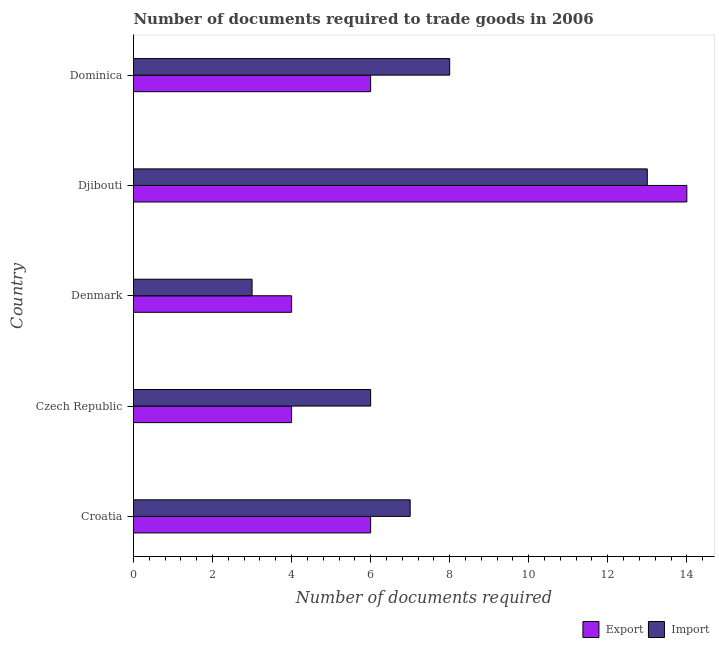How many different coloured bars are there?
Give a very brief answer. 2. How many bars are there on the 2nd tick from the top?
Offer a terse response. 2. What is the label of the 4th group of bars from the top?
Offer a terse response. Czech Republic. In how many cases, is the number of bars for a given country not equal to the number of legend labels?
Provide a succinct answer. 0. What is the number of documents required to import goods in Czech Republic?
Provide a succinct answer. 6. Across all countries, what is the maximum number of documents required to export goods?
Your response must be concise. 14. In which country was the number of documents required to import goods maximum?
Provide a succinct answer. Djibouti. In which country was the number of documents required to export goods minimum?
Provide a short and direct response. Czech Republic. What is the total number of documents required to import goods in the graph?
Your answer should be very brief. 37. What is the difference between the number of documents required to import goods in Denmark and the number of documents required to export goods in Dominica?
Your response must be concise. -3. What is the difference between the number of documents required to export goods and number of documents required to import goods in Croatia?
Offer a very short reply. -1. What is the ratio of the number of documents required to export goods in Croatia to that in Djibouti?
Provide a short and direct response. 0.43. Is the difference between the number of documents required to export goods in Czech Republic and Djibouti greater than the difference between the number of documents required to import goods in Czech Republic and Djibouti?
Offer a very short reply. No. Is the sum of the number of documents required to import goods in Denmark and Dominica greater than the maximum number of documents required to export goods across all countries?
Offer a terse response. No. What does the 2nd bar from the top in Croatia represents?
Your answer should be compact. Export. What does the 1st bar from the bottom in Croatia represents?
Make the answer very short. Export. How many bars are there?
Your response must be concise. 10. Are all the bars in the graph horizontal?
Give a very brief answer. Yes. Does the graph contain any zero values?
Offer a very short reply. No. Does the graph contain grids?
Make the answer very short. No. Where does the legend appear in the graph?
Ensure brevity in your answer.  Bottom right. What is the title of the graph?
Keep it short and to the point. Number of documents required to trade goods in 2006. Does "GDP" appear as one of the legend labels in the graph?
Give a very brief answer. No. What is the label or title of the X-axis?
Offer a terse response. Number of documents required. What is the Number of documents required in Import in Croatia?
Give a very brief answer. 7. What is the Number of documents required in Export in Czech Republic?
Your response must be concise. 4. What is the Number of documents required in Import in Czech Republic?
Your answer should be very brief. 6. What is the Number of documents required in Export in Denmark?
Ensure brevity in your answer.  4. What is the Number of documents required of Import in Denmark?
Your response must be concise. 3. What is the Number of documents required in Import in Djibouti?
Ensure brevity in your answer.  13. What is the Number of documents required in Export in Dominica?
Make the answer very short. 6. Across all countries, what is the minimum Number of documents required of Export?
Provide a short and direct response. 4. What is the total Number of documents required of Import in the graph?
Give a very brief answer. 37. What is the difference between the Number of documents required in Export in Croatia and that in Czech Republic?
Offer a terse response. 2. What is the difference between the Number of documents required in Import in Croatia and that in Czech Republic?
Provide a short and direct response. 1. What is the difference between the Number of documents required in Import in Croatia and that in Djibouti?
Your response must be concise. -6. What is the difference between the Number of documents required of Import in Croatia and that in Dominica?
Offer a terse response. -1. What is the difference between the Number of documents required in Export in Czech Republic and that in Denmark?
Your answer should be compact. 0. What is the difference between the Number of documents required in Import in Czech Republic and that in Denmark?
Your response must be concise. 3. What is the difference between the Number of documents required in Export in Czech Republic and that in Djibouti?
Your answer should be compact. -10. What is the difference between the Number of documents required in Import in Czech Republic and that in Dominica?
Provide a short and direct response. -2. What is the difference between the Number of documents required in Import in Denmark and that in Djibouti?
Your answer should be very brief. -10. What is the difference between the Number of documents required of Export in Denmark and that in Dominica?
Your response must be concise. -2. What is the difference between the Number of documents required in Export in Djibouti and that in Dominica?
Provide a short and direct response. 8. What is the difference between the Number of documents required of Export in Croatia and the Number of documents required of Import in Dominica?
Your answer should be very brief. -2. What is the difference between the Number of documents required in Export in Czech Republic and the Number of documents required in Import in Djibouti?
Your answer should be very brief. -9. What is the difference between the Number of documents required of Export in Czech Republic and the Number of documents required of Import in Dominica?
Keep it short and to the point. -4. What is the difference between the Number of documents required of Export in Denmark and the Number of documents required of Import in Djibouti?
Give a very brief answer. -9. What is the average Number of documents required of Import per country?
Your response must be concise. 7.4. What is the difference between the Number of documents required in Export and Number of documents required in Import in Croatia?
Provide a succinct answer. -1. What is the difference between the Number of documents required in Export and Number of documents required in Import in Dominica?
Make the answer very short. -2. What is the ratio of the Number of documents required in Export in Croatia to that in Czech Republic?
Your answer should be very brief. 1.5. What is the ratio of the Number of documents required in Export in Croatia to that in Denmark?
Give a very brief answer. 1.5. What is the ratio of the Number of documents required of Import in Croatia to that in Denmark?
Your answer should be compact. 2.33. What is the ratio of the Number of documents required in Export in Croatia to that in Djibouti?
Provide a short and direct response. 0.43. What is the ratio of the Number of documents required of Import in Croatia to that in Djibouti?
Give a very brief answer. 0.54. What is the ratio of the Number of documents required of Export in Croatia to that in Dominica?
Provide a short and direct response. 1. What is the ratio of the Number of documents required in Import in Croatia to that in Dominica?
Your response must be concise. 0.88. What is the ratio of the Number of documents required of Import in Czech Republic to that in Denmark?
Your answer should be very brief. 2. What is the ratio of the Number of documents required of Export in Czech Republic to that in Djibouti?
Offer a terse response. 0.29. What is the ratio of the Number of documents required in Import in Czech Republic to that in Djibouti?
Your answer should be compact. 0.46. What is the ratio of the Number of documents required of Export in Denmark to that in Djibouti?
Offer a very short reply. 0.29. What is the ratio of the Number of documents required in Import in Denmark to that in Djibouti?
Your answer should be compact. 0.23. What is the ratio of the Number of documents required in Export in Denmark to that in Dominica?
Offer a terse response. 0.67. What is the ratio of the Number of documents required of Import in Denmark to that in Dominica?
Give a very brief answer. 0.38. What is the ratio of the Number of documents required in Export in Djibouti to that in Dominica?
Offer a terse response. 2.33. What is the ratio of the Number of documents required of Import in Djibouti to that in Dominica?
Provide a short and direct response. 1.62. What is the difference between the highest and the second highest Number of documents required in Import?
Offer a very short reply. 5. What is the difference between the highest and the lowest Number of documents required in Export?
Your answer should be compact. 10. What is the difference between the highest and the lowest Number of documents required of Import?
Offer a terse response. 10. 